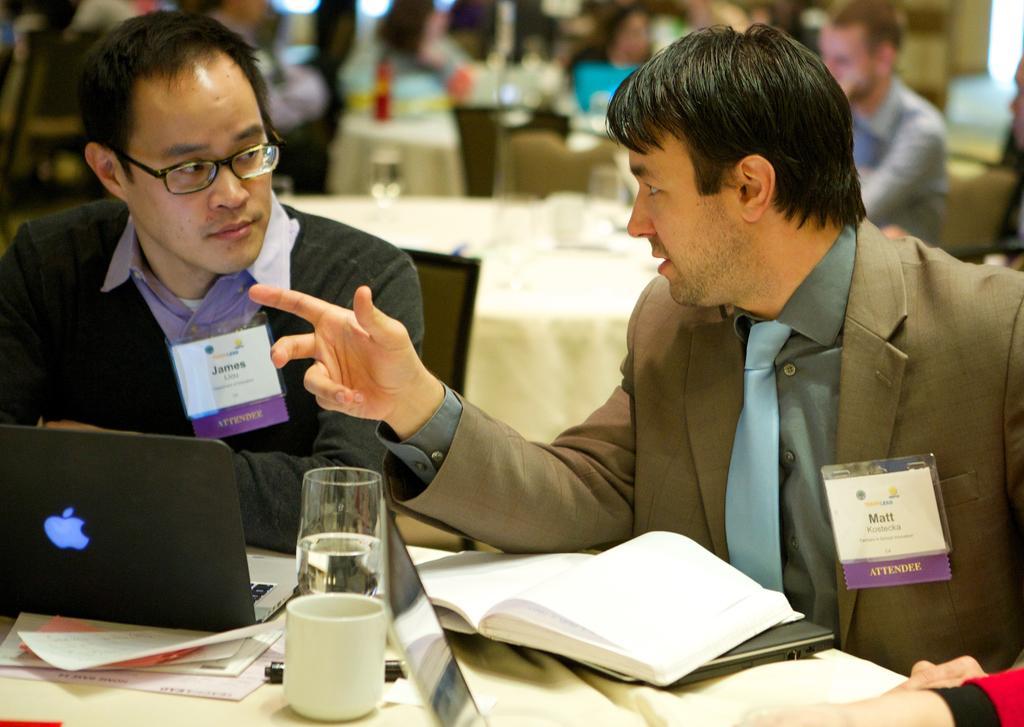In one or two sentences, can you explain what this image depicts? In this image there are two persons sitting on the chairs as we can see in the middle of this image. There is one laptop on the left side of this image and there is a glasses and some books are kept on a table in the bottom of this image. There are some tables and persons are sitting as we can see in the background. 